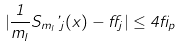Convert formula to latex. <formula><loc_0><loc_0><loc_500><loc_500>| \frac { 1 } { m _ { l } } S _ { m _ { l } } \varphi _ { j } ( x ) - \alpha _ { j } | \leq 4 \beta _ { p }</formula> 